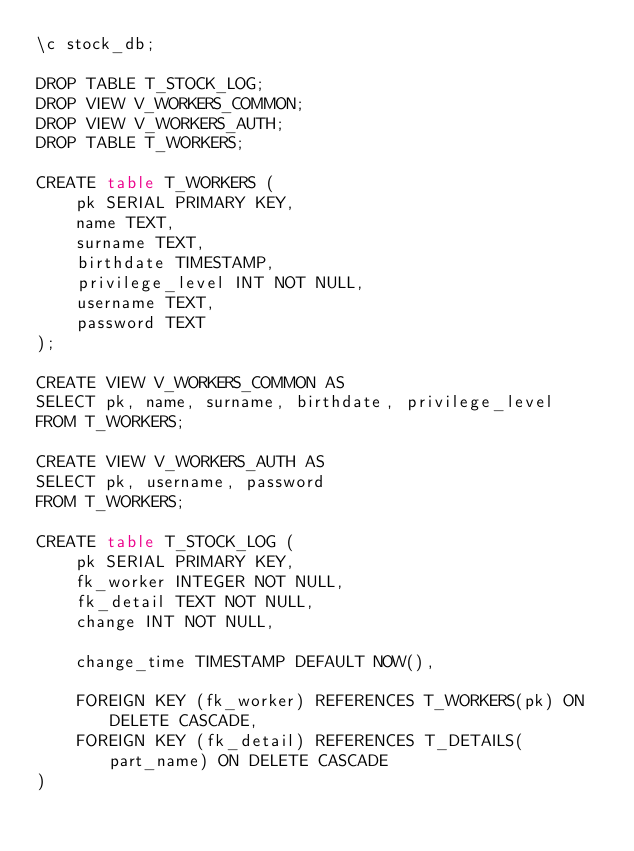Convert code to text. <code><loc_0><loc_0><loc_500><loc_500><_SQL_>\c stock_db;

DROP TABLE T_STOCK_LOG;
DROP VIEW V_WORKERS_COMMON;
DROP VIEW V_WORKERS_AUTH;
DROP TABLE T_WORKERS;

CREATE table T_WORKERS (
    pk SERIAL PRIMARY KEY,
    name TEXT,
    surname TEXT,
    birthdate TIMESTAMP,
    privilege_level INT NOT NULL,
    username TEXT,
    password TEXT
);

CREATE VIEW V_WORKERS_COMMON AS
SELECT pk, name, surname, birthdate, privilege_level
FROM T_WORKERS;

CREATE VIEW V_WORKERS_AUTH AS
SELECT pk, username, password
FROM T_WORKERS;

CREATE table T_STOCK_LOG (
    pk SERIAL PRIMARY KEY,
    fk_worker INTEGER NOT NULL,
    fk_detail TEXT NOT NULL,
    change INT NOT NULL,

    change_time TIMESTAMP DEFAULT NOW(),

    FOREIGN KEY (fk_worker) REFERENCES T_WORKERS(pk) ON DELETE CASCADE,
    FOREIGN KEY (fk_detail) REFERENCES T_DETAILS(part_name) ON DELETE CASCADE
)</code> 